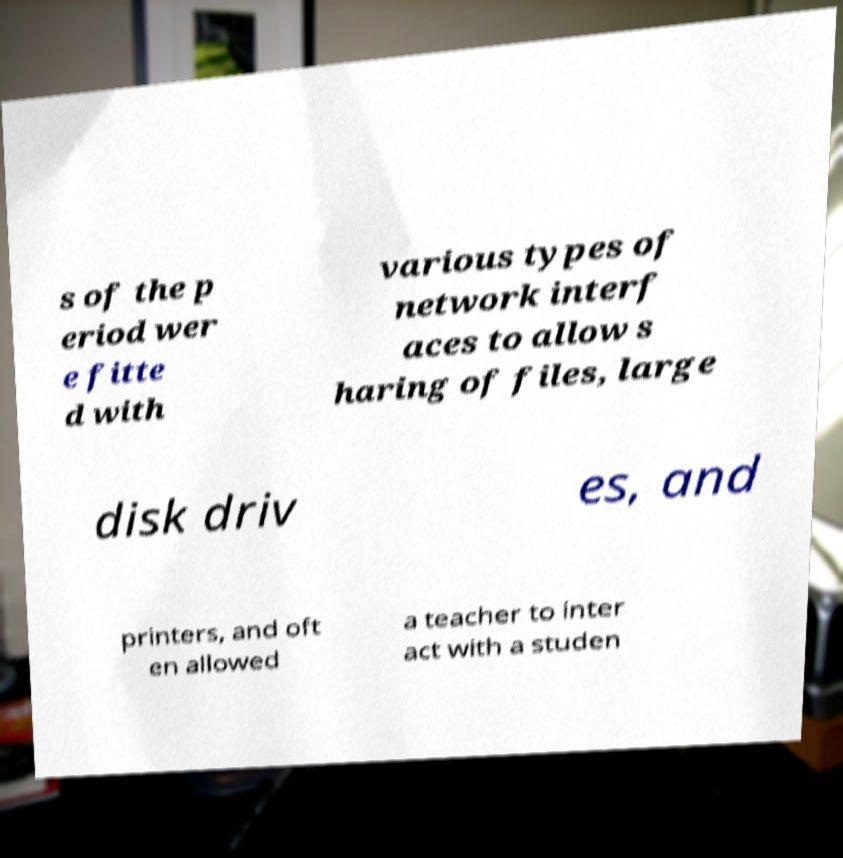There's text embedded in this image that I need extracted. Can you transcribe it verbatim? s of the p eriod wer e fitte d with various types of network interf aces to allow s haring of files, large disk driv es, and printers, and oft en allowed a teacher to inter act with a studen 